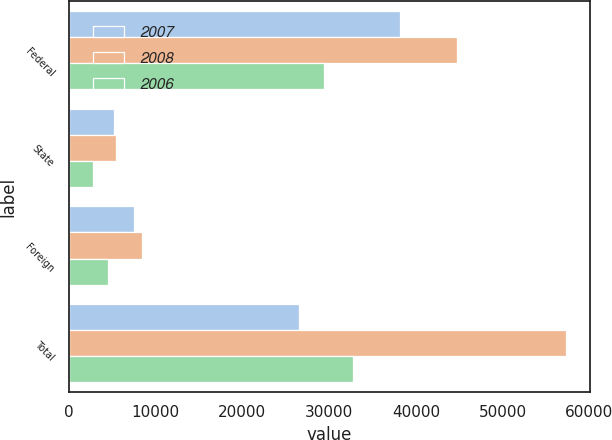<chart> <loc_0><loc_0><loc_500><loc_500><stacked_bar_chart><ecel><fcel>Federal<fcel>State<fcel>Foreign<fcel>Total<nl><fcel>2007<fcel>38149<fcel>5213<fcel>7494<fcel>26508<nl><fcel>2008<fcel>44737<fcel>5391<fcel>8399<fcel>57262<nl><fcel>2006<fcel>29376<fcel>2804<fcel>4560<fcel>32709<nl></chart> 